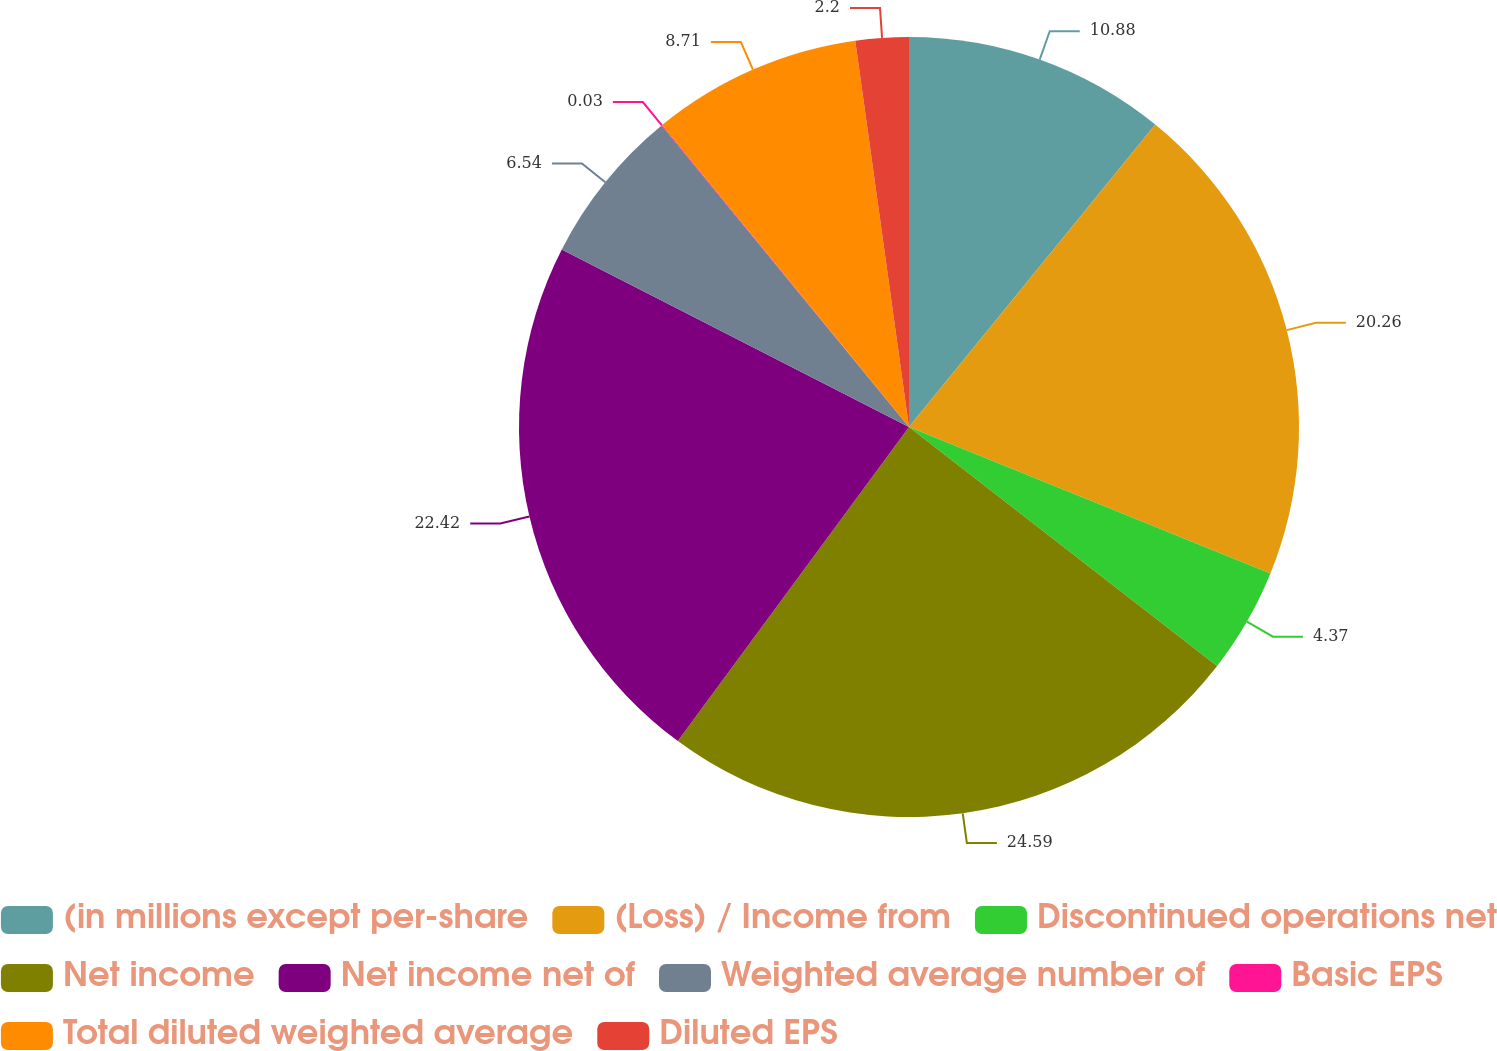<chart> <loc_0><loc_0><loc_500><loc_500><pie_chart><fcel>(in millions except per-share<fcel>(Loss) / Income from<fcel>Discontinued operations net<fcel>Net income<fcel>Net income net of<fcel>Weighted average number of<fcel>Basic EPS<fcel>Total diluted weighted average<fcel>Diluted EPS<nl><fcel>10.88%<fcel>20.26%<fcel>4.37%<fcel>24.6%<fcel>22.43%<fcel>6.54%<fcel>0.03%<fcel>8.71%<fcel>2.2%<nl></chart> 